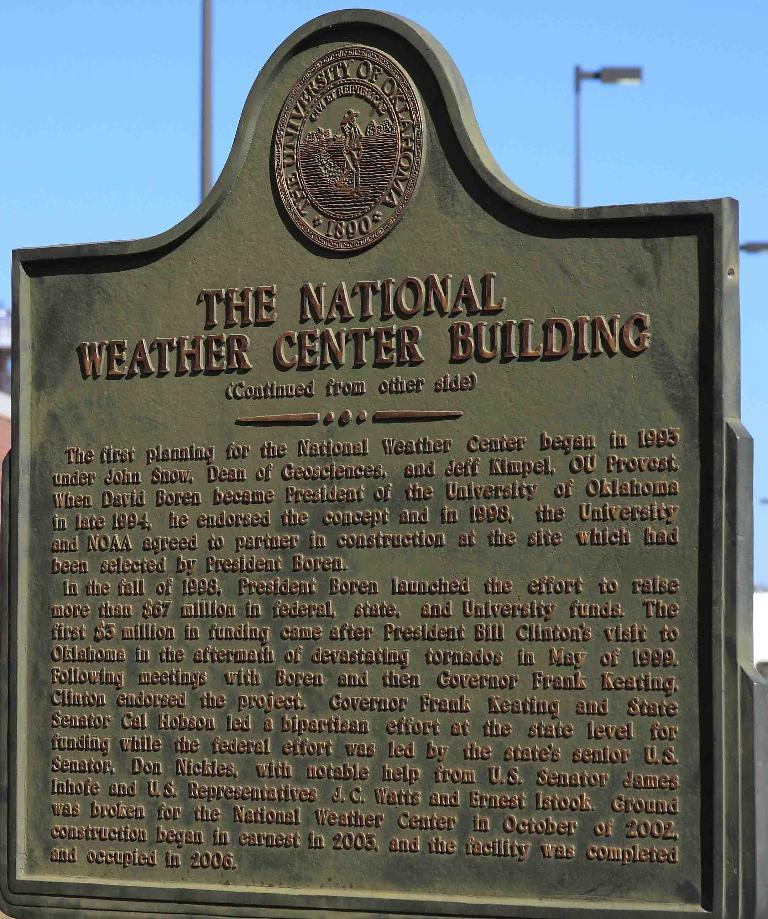<image>
Describe the image concisely. An stonehedge with information about the National Weather Center Building sits beneath a blue sky 